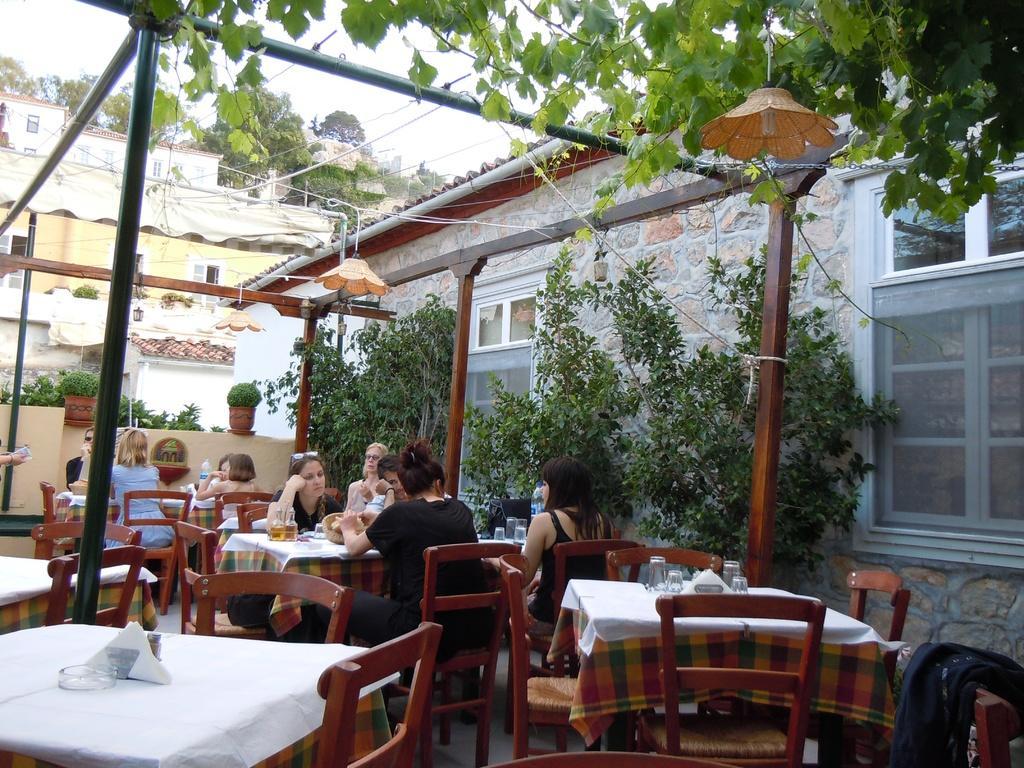In one or two sentences, can you explain what this image depicts? As we can see in the image there is a sky, trees, buildings, plants, few people sitting on chairs and a table. On table there are glasses and plates. 